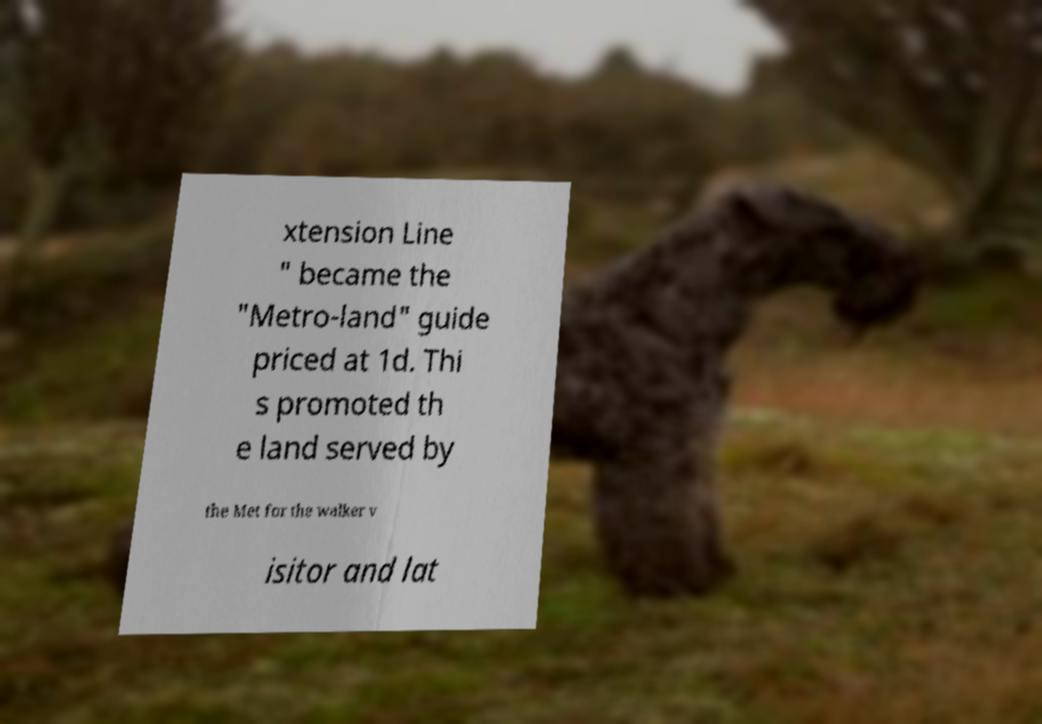For documentation purposes, I need the text within this image transcribed. Could you provide that? xtension Line " became the "Metro-land" guide priced at 1d. Thi s promoted th e land served by the Met for the walker v isitor and lat 